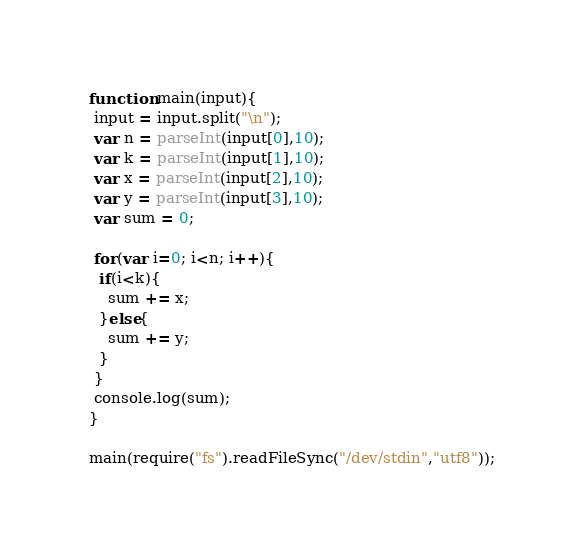Convert code to text. <code><loc_0><loc_0><loc_500><loc_500><_JavaScript_>function main(input){
 input = input.split("\n");
 var n = parseInt(input[0],10);
 var k = parseInt(input[1],10);
 var x = parseInt(input[2],10);
 var y = parseInt(input[3],10);
 var sum = 0;
  
 for(var i=0; i<n; i++){
  if(i<k){
    sum += x;
  }else{
    sum += y; 
  }
 }
 console.log(sum);  
}

main(require("fs").readFileSync("/dev/stdin","utf8"));</code> 